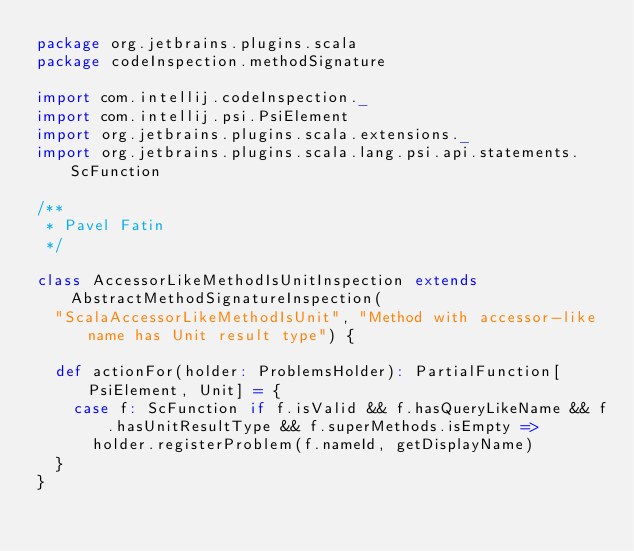<code> <loc_0><loc_0><loc_500><loc_500><_Scala_>package org.jetbrains.plugins.scala
package codeInspection.methodSignature

import com.intellij.codeInspection._
import com.intellij.psi.PsiElement
import org.jetbrains.plugins.scala.extensions._
import org.jetbrains.plugins.scala.lang.psi.api.statements.ScFunction

/**
 * Pavel Fatin
 */

class AccessorLikeMethodIsUnitInspection extends AbstractMethodSignatureInspection(
  "ScalaAccessorLikeMethodIsUnit", "Method with accessor-like name has Unit result type") {

  def actionFor(holder: ProblemsHolder): PartialFunction[PsiElement, Unit] = {
    case f: ScFunction if f.isValid && f.hasQueryLikeName && f.hasUnitResultType && f.superMethods.isEmpty =>
      holder.registerProblem(f.nameId, getDisplayName)
  }
}</code> 